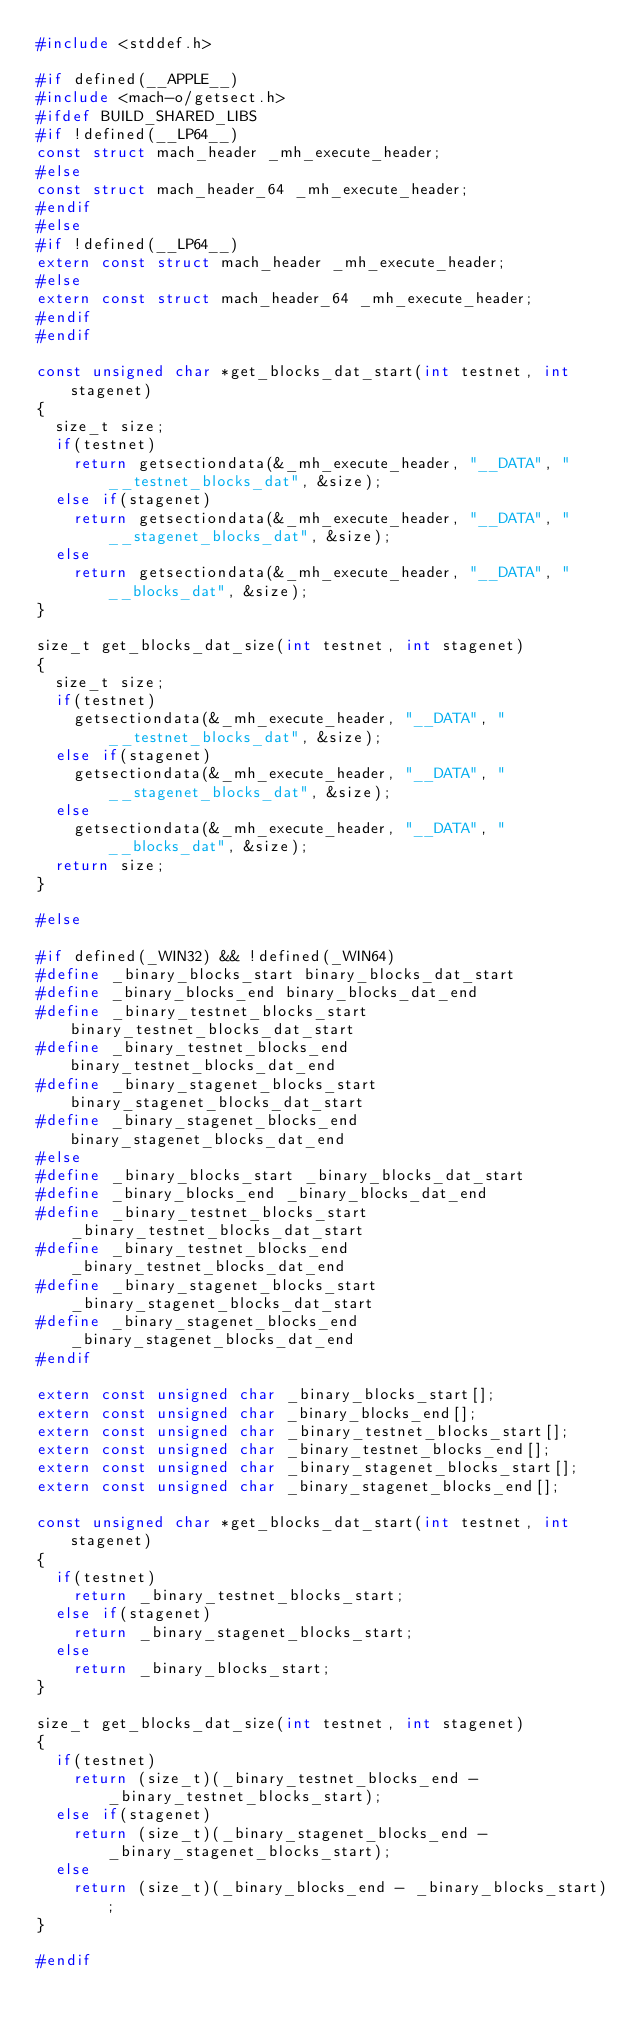<code> <loc_0><loc_0><loc_500><loc_500><_C_>#include <stddef.h>

#if defined(__APPLE__)
#include <mach-o/getsect.h>
#ifdef BUILD_SHARED_LIBS
#if !defined(__LP64__)
const struct mach_header _mh_execute_header;
#else
const struct mach_header_64 _mh_execute_header;
#endif
#else
#if !defined(__LP64__)
extern const struct mach_header _mh_execute_header;
#else
extern const struct mach_header_64 _mh_execute_header;
#endif
#endif

const unsigned char *get_blocks_dat_start(int testnet, int stagenet)
{
	size_t size;
	if(testnet)
		return getsectiondata(&_mh_execute_header, "__DATA", "__testnet_blocks_dat", &size);
	else if(stagenet)
		return getsectiondata(&_mh_execute_header, "__DATA", "__stagenet_blocks_dat", &size);
	else
		return getsectiondata(&_mh_execute_header, "__DATA", "__blocks_dat", &size);
}

size_t get_blocks_dat_size(int testnet, int stagenet)
{
	size_t size;
	if(testnet)
		getsectiondata(&_mh_execute_header, "__DATA", "__testnet_blocks_dat", &size);
	else if(stagenet)
		getsectiondata(&_mh_execute_header, "__DATA", "__stagenet_blocks_dat", &size);
	else
		getsectiondata(&_mh_execute_header, "__DATA", "__blocks_dat", &size);
	return size;
}

#else

#if defined(_WIN32) && !defined(_WIN64)
#define _binary_blocks_start binary_blocks_dat_start
#define _binary_blocks_end binary_blocks_dat_end
#define _binary_testnet_blocks_start binary_testnet_blocks_dat_start
#define _binary_testnet_blocks_end binary_testnet_blocks_dat_end
#define _binary_stagenet_blocks_start binary_stagenet_blocks_dat_start
#define _binary_stagenet_blocks_end binary_stagenet_blocks_dat_end
#else
#define _binary_blocks_start _binary_blocks_dat_start
#define _binary_blocks_end _binary_blocks_dat_end
#define _binary_testnet_blocks_start _binary_testnet_blocks_dat_start
#define _binary_testnet_blocks_end _binary_testnet_blocks_dat_end
#define _binary_stagenet_blocks_start _binary_stagenet_blocks_dat_start
#define _binary_stagenet_blocks_end _binary_stagenet_blocks_dat_end
#endif

extern const unsigned char _binary_blocks_start[];
extern const unsigned char _binary_blocks_end[];
extern const unsigned char _binary_testnet_blocks_start[];
extern const unsigned char _binary_testnet_blocks_end[];
extern const unsigned char _binary_stagenet_blocks_start[];
extern const unsigned char _binary_stagenet_blocks_end[];

const unsigned char *get_blocks_dat_start(int testnet, int stagenet)
{
	if(testnet)
		return _binary_testnet_blocks_start;
	else if(stagenet)
		return _binary_stagenet_blocks_start;
	else
		return _binary_blocks_start;
}

size_t get_blocks_dat_size(int testnet, int stagenet)
{
	if(testnet)
		return (size_t)(_binary_testnet_blocks_end - _binary_testnet_blocks_start);
	else if(stagenet)
		return (size_t)(_binary_stagenet_blocks_end - _binary_stagenet_blocks_start);
	else
		return (size_t)(_binary_blocks_end - _binary_blocks_start);
}

#endif
</code> 